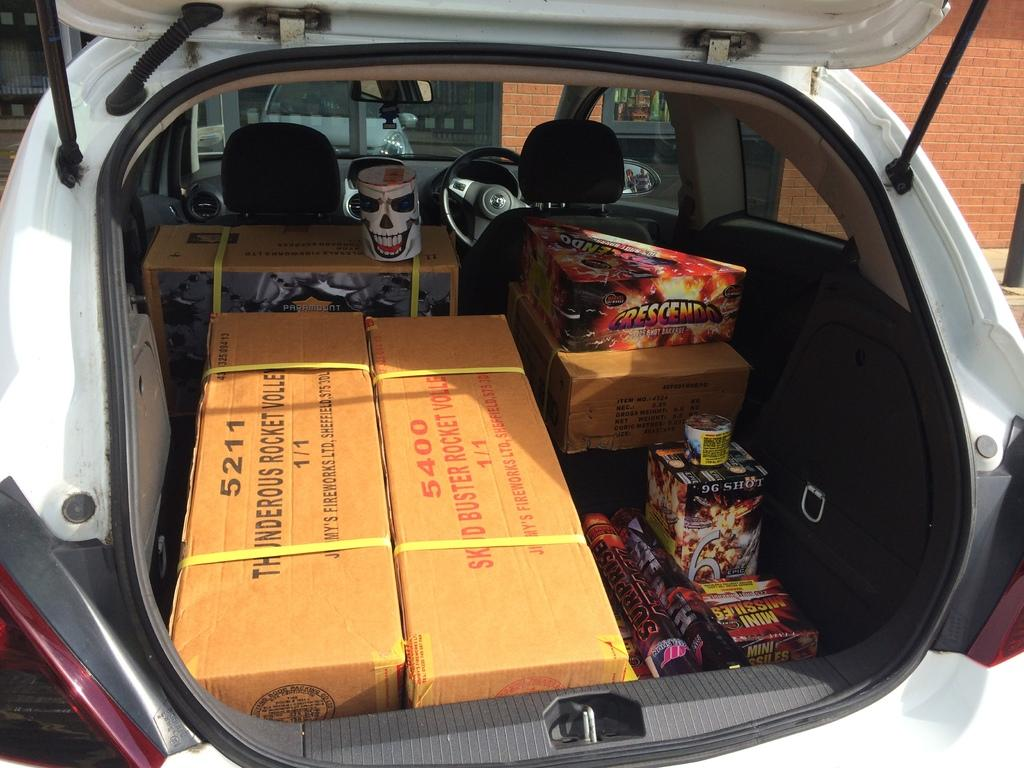What color is the vehicle in the image? The vehicle in the image is white. What can be found inside the vehicle? There are objects in the vehicle. What is visible in the background of the image? There is a wall in the background of the image. Can you see any spots on the vehicle in the image? There is no mention of spots on the vehicle in the provided facts, so it cannot be determined from the image. 